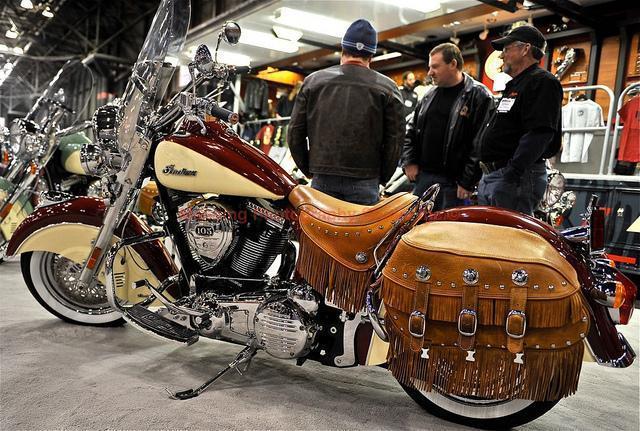How many men are visible?
Give a very brief answer. 3. How many people are there?
Give a very brief answer. 3. How many motorcycles are there?
Give a very brief answer. 3. 